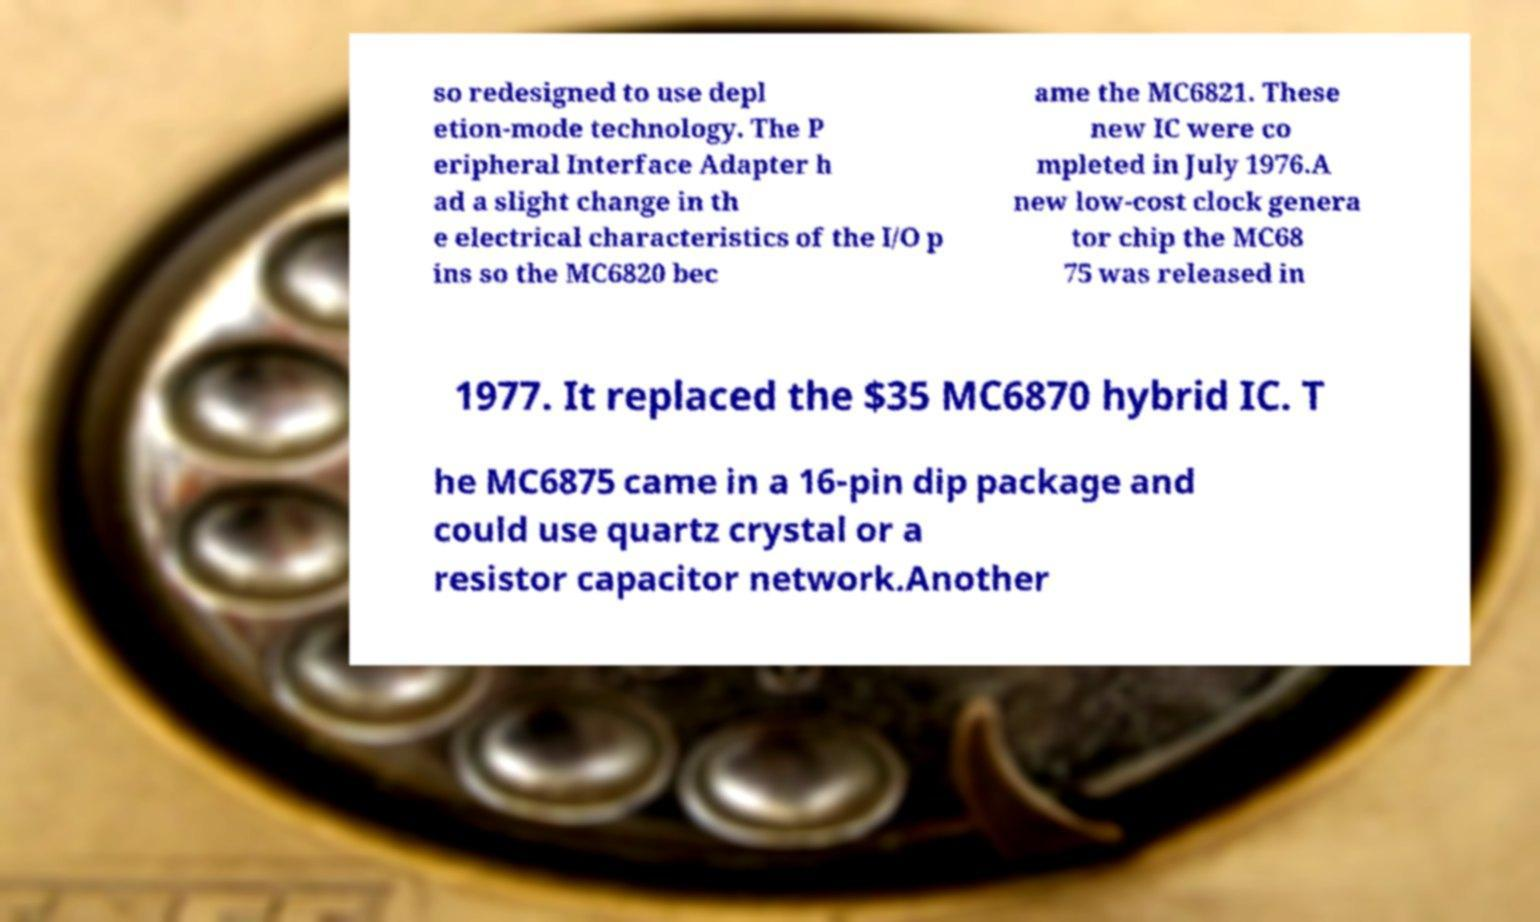Can you accurately transcribe the text from the provided image for me? so redesigned to use depl etion-mode technology. The P eripheral Interface Adapter h ad a slight change in th e electrical characteristics of the I/O p ins so the MC6820 bec ame the MC6821. These new IC were co mpleted in July 1976.A new low-cost clock genera tor chip the MC68 75 was released in 1977. It replaced the $35 MC6870 hybrid IC. T he MC6875 came in a 16-pin dip package and could use quartz crystal or a resistor capacitor network.Another 